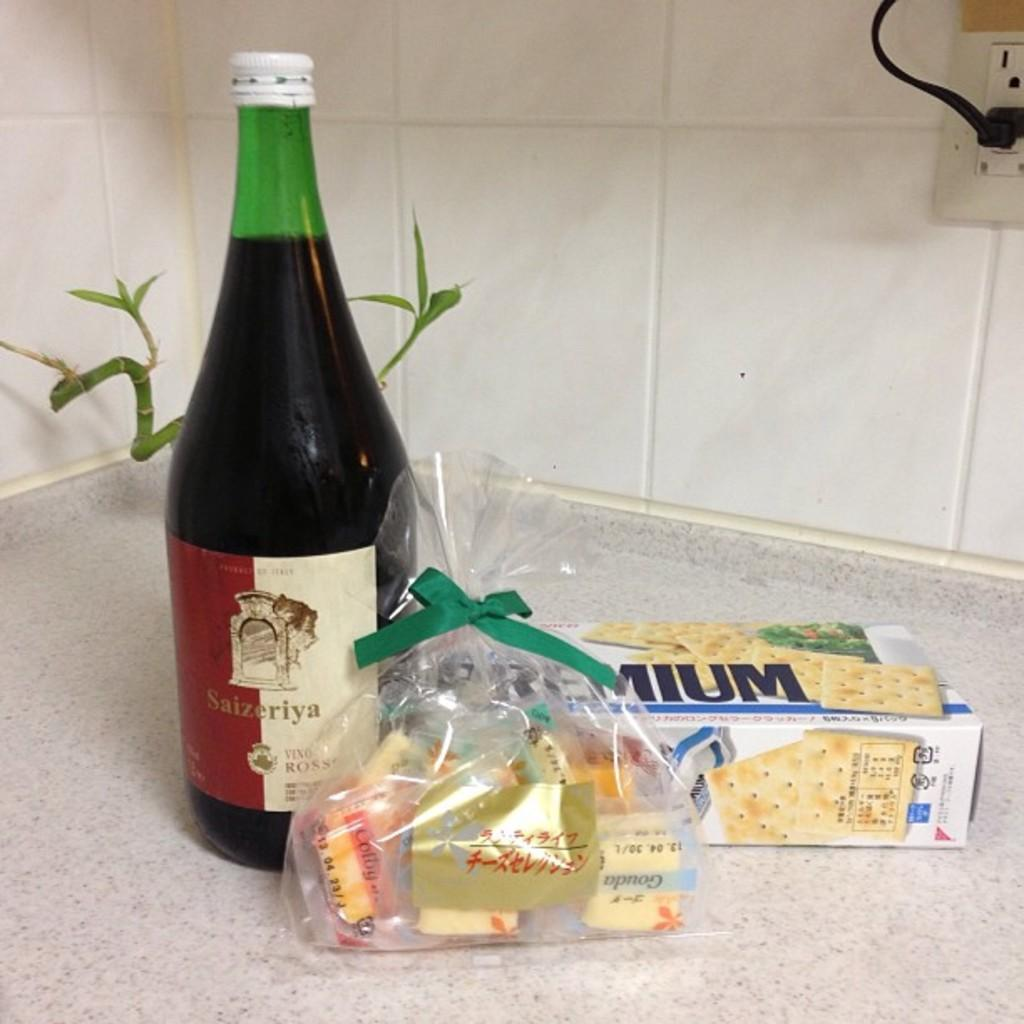<image>
Describe the image concisely. A bottle of Saizeriya is on a counter next to Premium saltine crackers. 